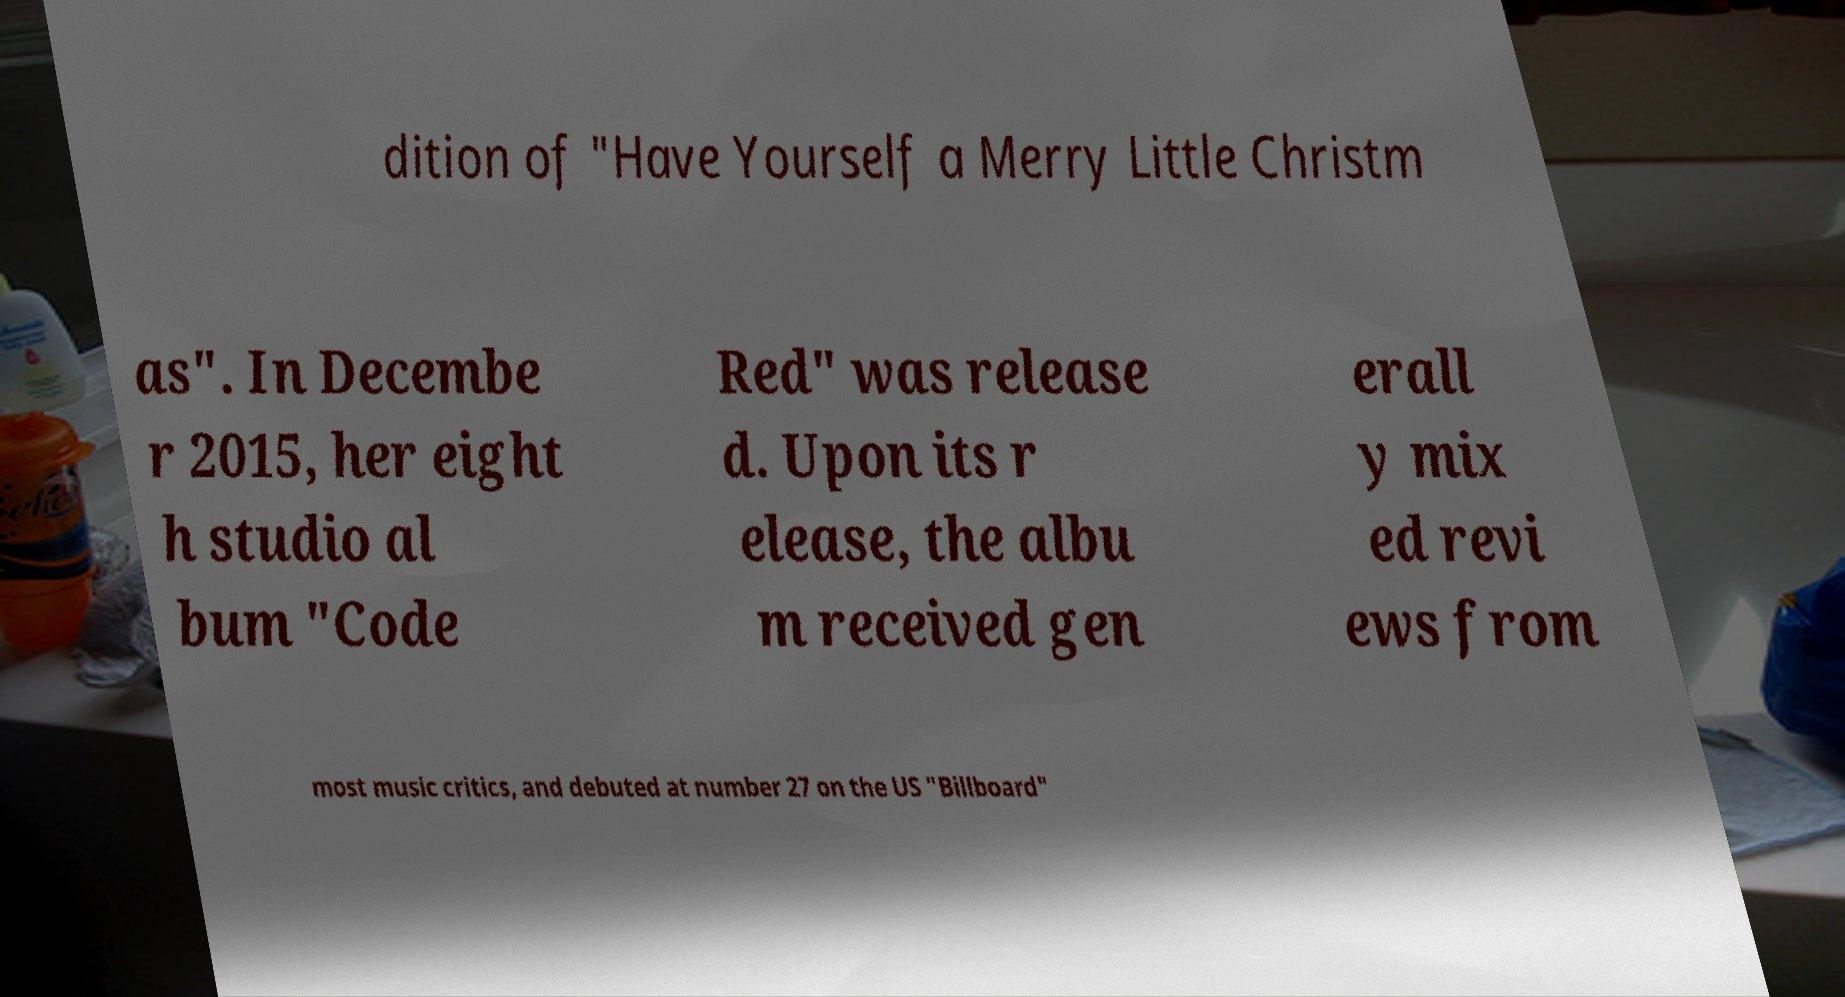Please identify and transcribe the text found in this image. dition of "Have Yourself a Merry Little Christm as". In Decembe r 2015, her eight h studio al bum "Code Red" was release d. Upon its r elease, the albu m received gen erall y mix ed revi ews from most music critics, and debuted at number 27 on the US "Billboard" 